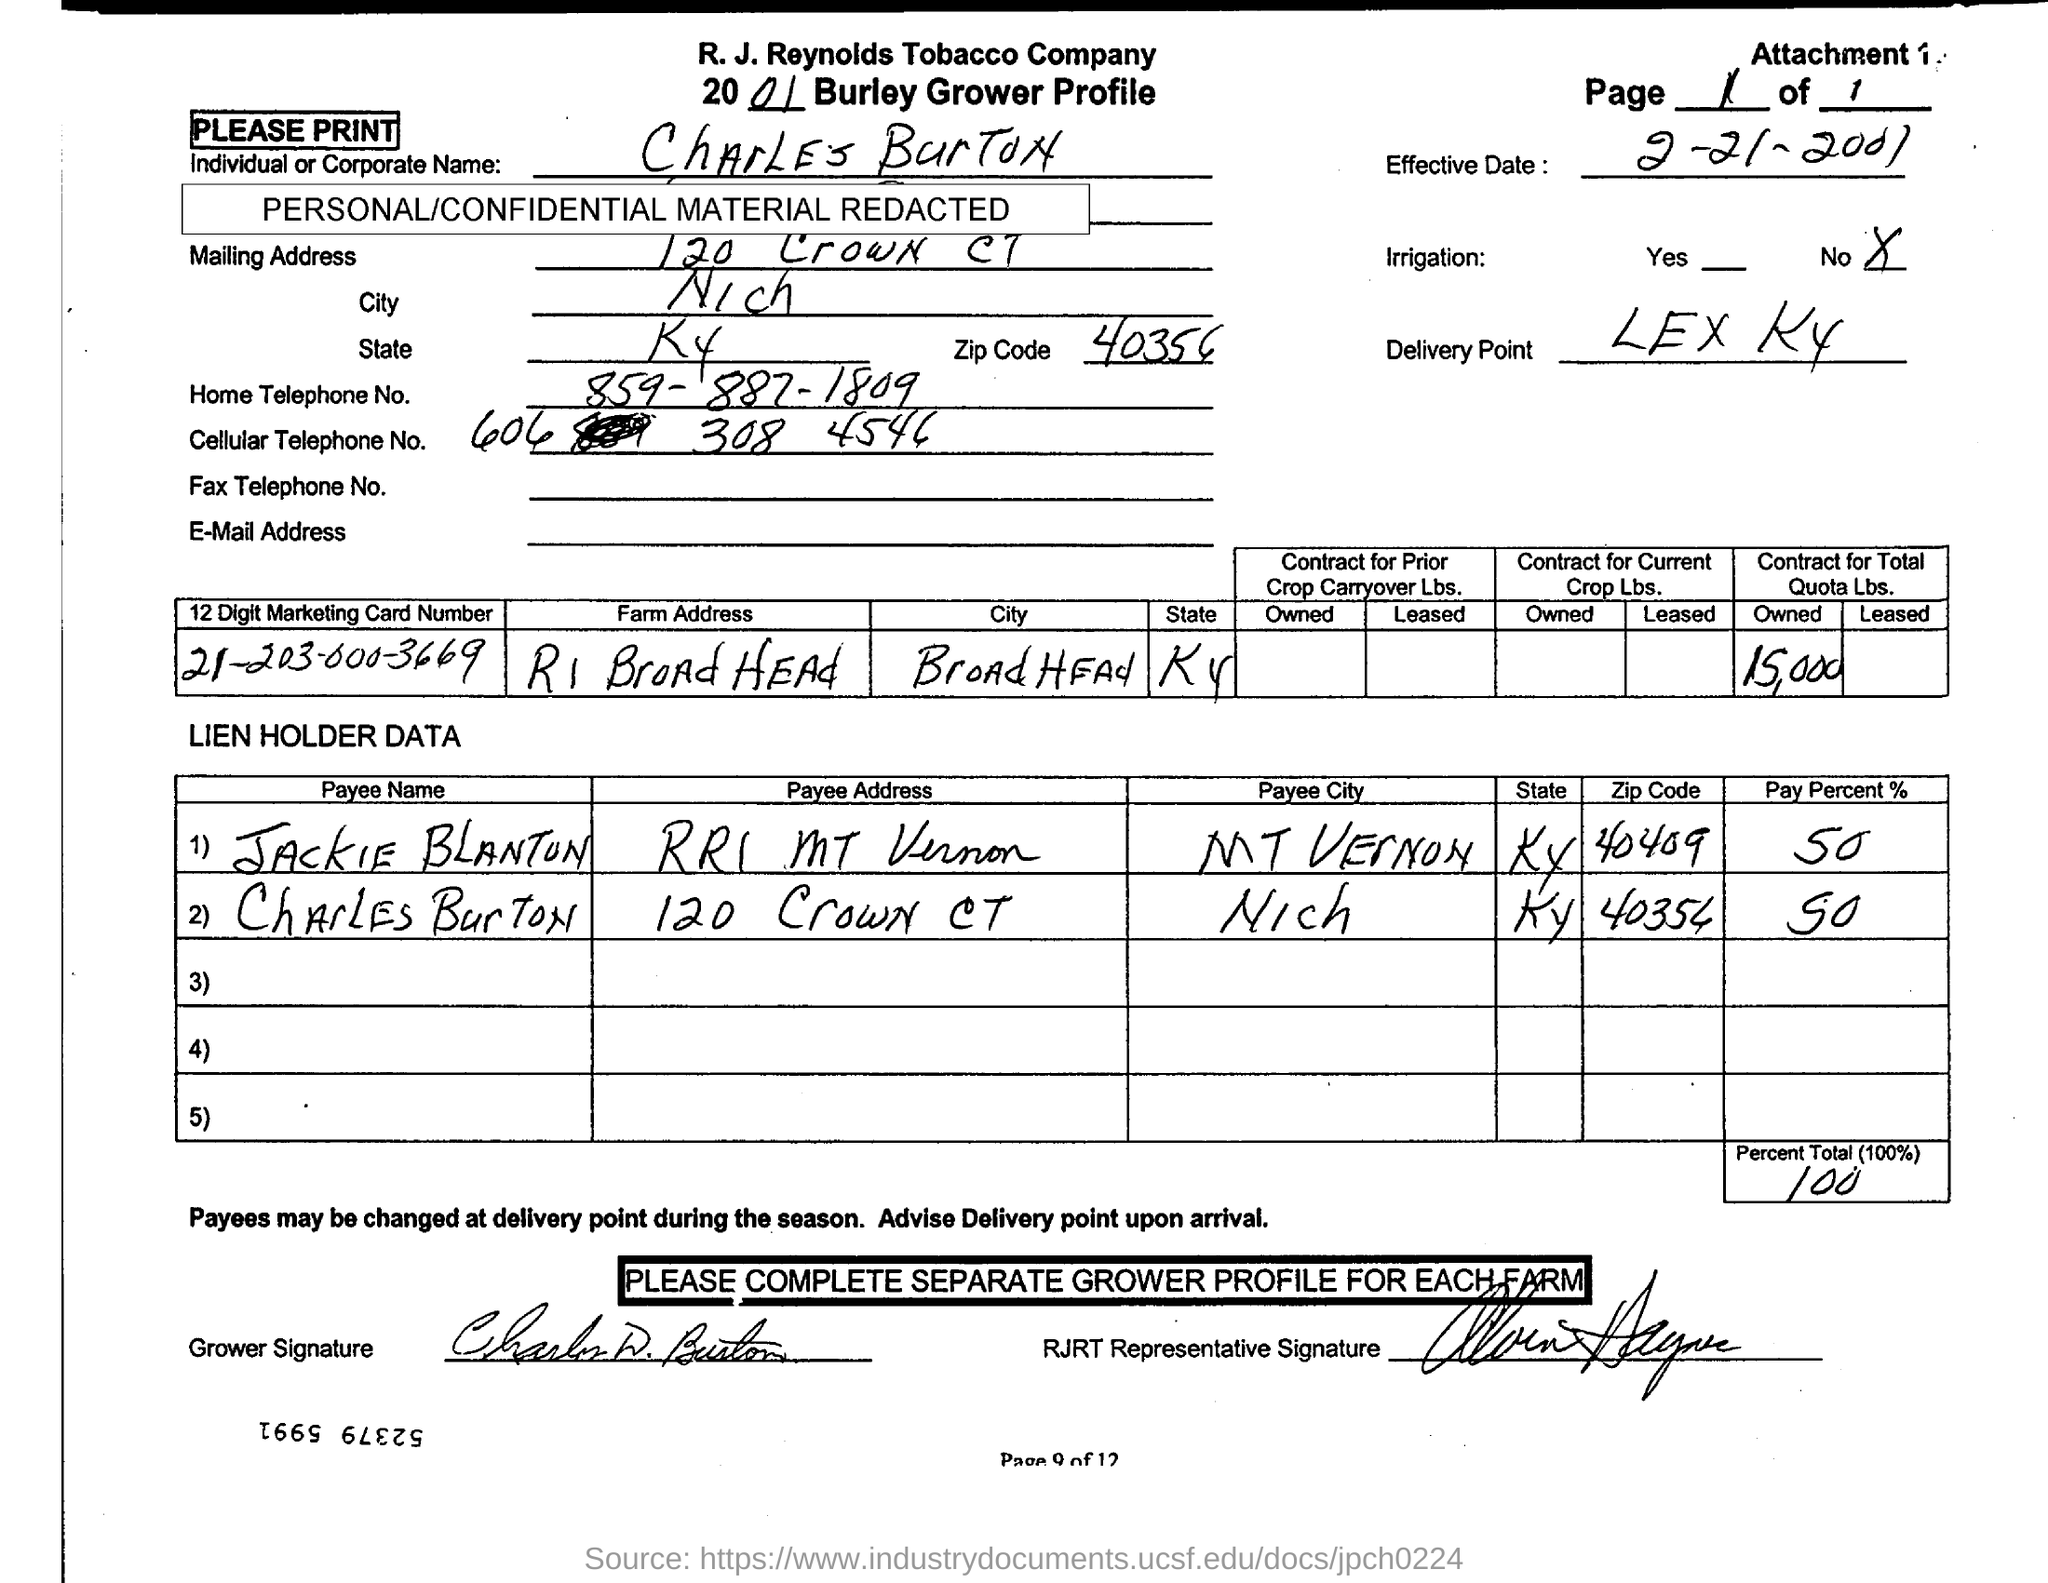Can you tell me the effective date of the contract? The effective date of the contract, as indicated on the document, is the 27th of March, 2001. 